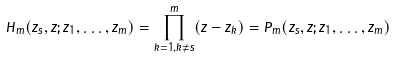<formula> <loc_0><loc_0><loc_500><loc_500>H _ { m } ( z _ { s } , z ; z _ { 1 } , \dots , z _ { m } ) = \prod _ { k = 1 , k \ne s } ^ { m } ( z - z _ { k } ) = P _ { m } ( z _ { s } , z ; z _ { 1 } , \dots , z _ { m } )</formula> 